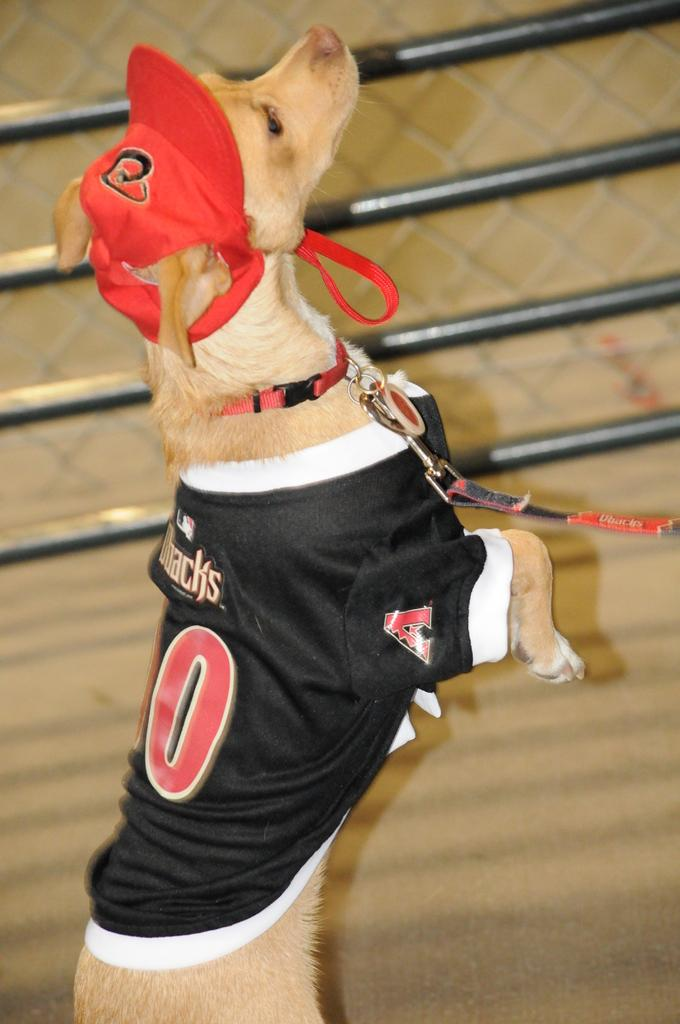<image>
Present a compact description of the photo's key features. A dog on a leash wears a Dbacks baseball jersey. 